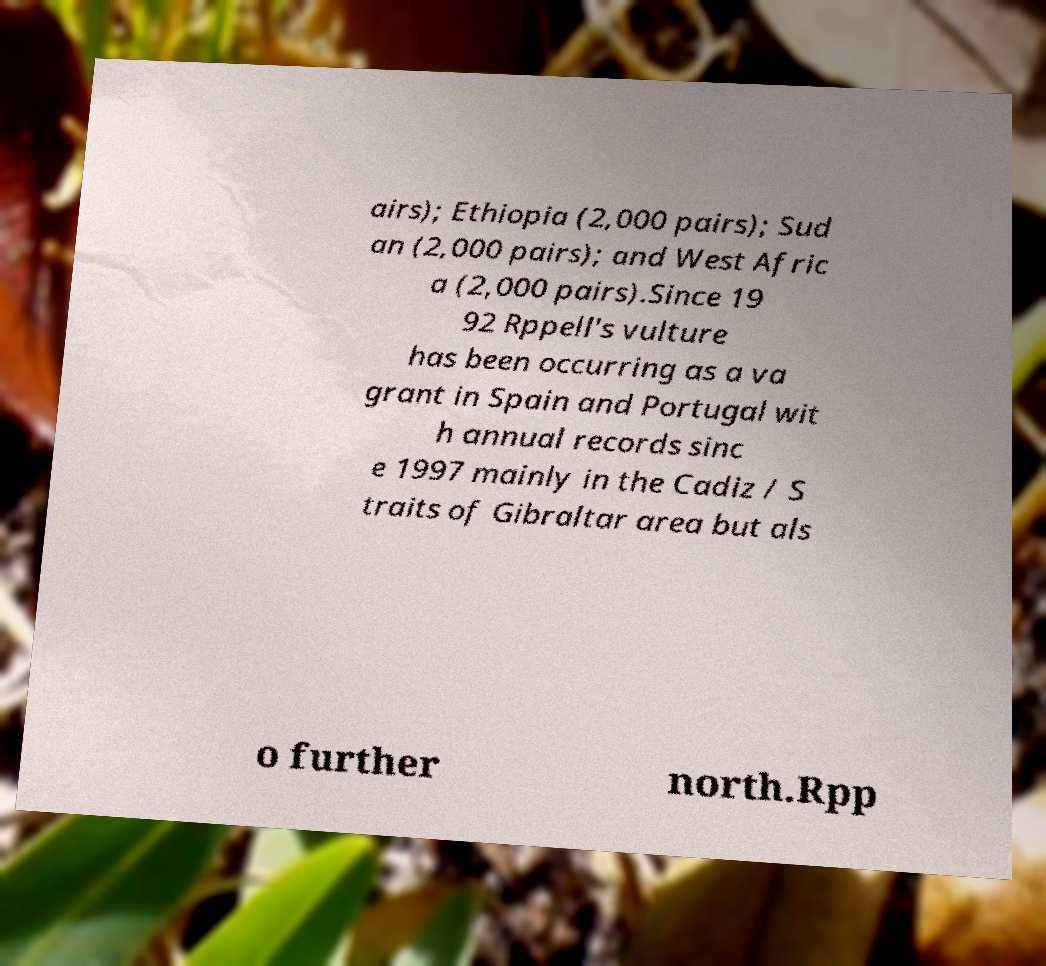There's text embedded in this image that I need extracted. Can you transcribe it verbatim? airs); Ethiopia (2,000 pairs); Sud an (2,000 pairs); and West Afric a (2,000 pairs).Since 19 92 Rppell's vulture has been occurring as a va grant in Spain and Portugal wit h annual records sinc e 1997 mainly in the Cadiz / S traits of Gibraltar area but als o further north.Rpp 